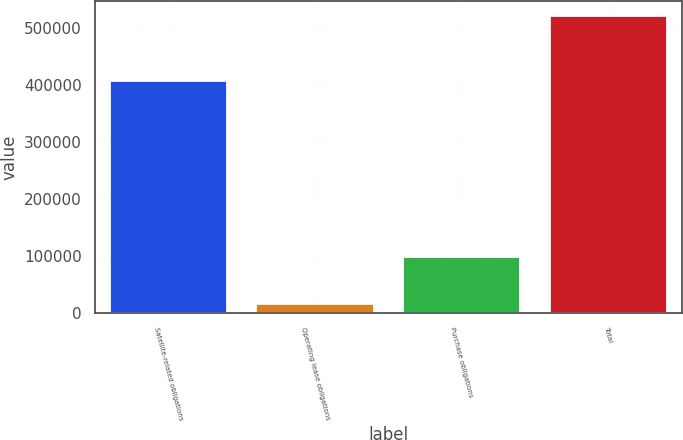<chart> <loc_0><loc_0><loc_500><loc_500><bar_chart><fcel>Satellite-related obligations<fcel>Operating lease obligations<fcel>Purchase obligations<fcel>Total<nl><fcel>407175<fcel>15746<fcel>98060<fcel>520981<nl></chart> 